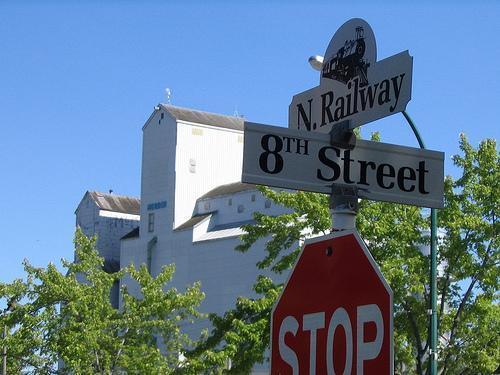How many signs are on the pole?
Give a very brief answer. 3. 